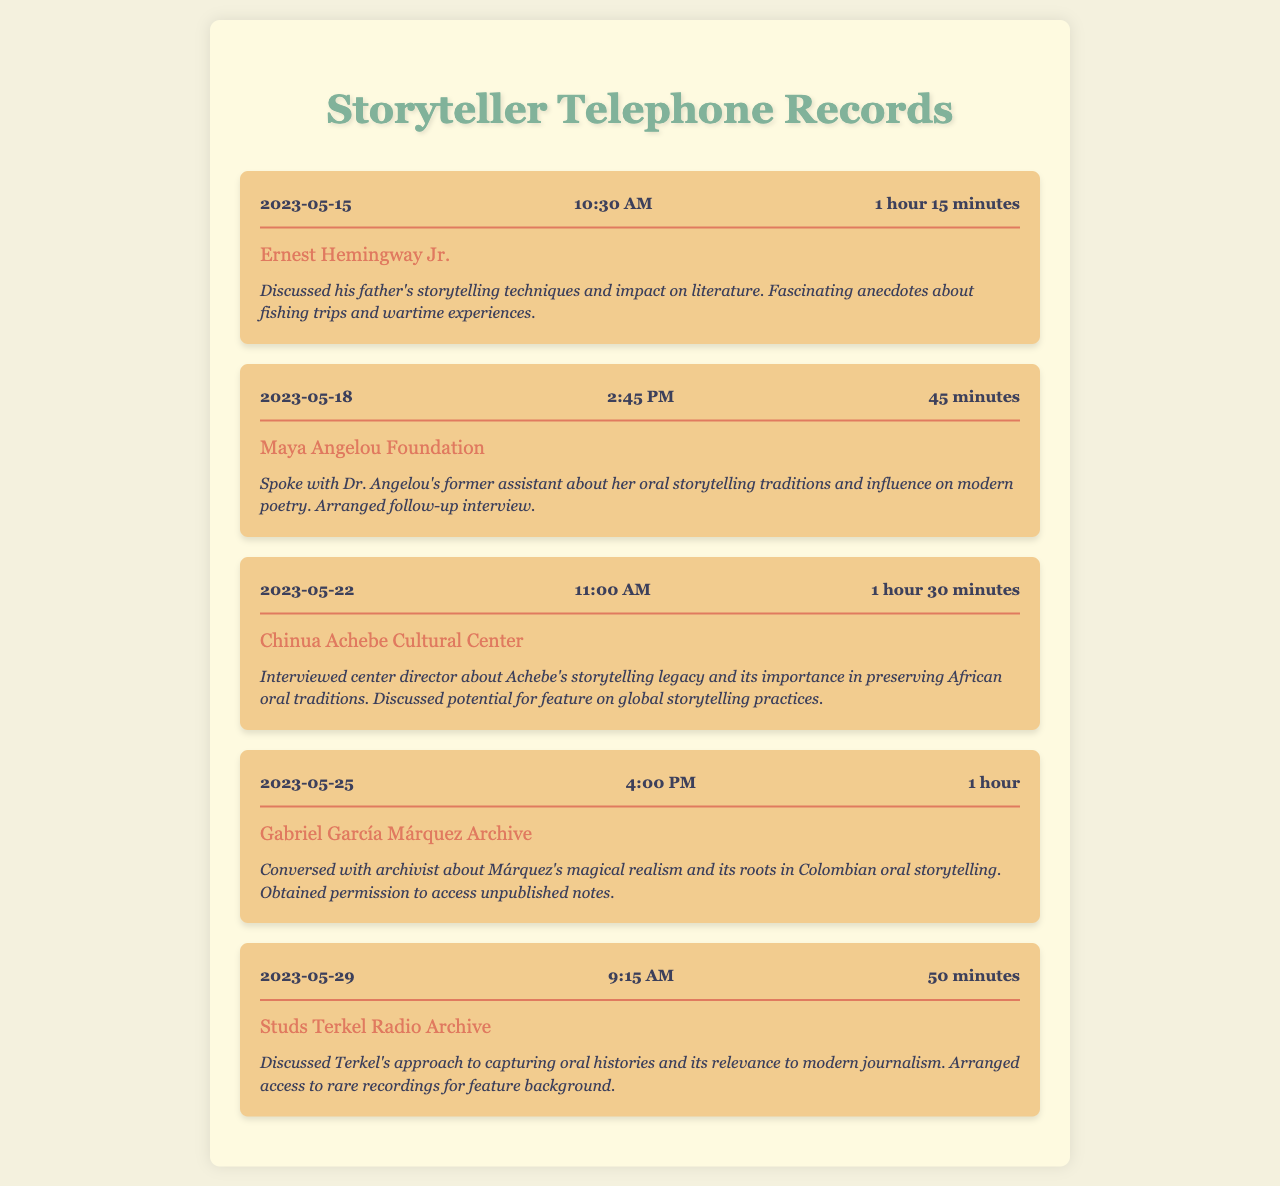What was the date of the first call? The document lists the call records in chronological order, with the first call being on May 15, 2023.
Answer: 2023-05-15 How long was the call with the Maya Angelou Foundation? The call duration for the Maya Angelou Foundation on May 18, 2023, is listed as 45 minutes.
Answer: 45 minutes Who did the journalist speak with on May 22, 2023? The call entry for May 22, 2023, indicates that the journalist spoke with the director of the Chinua Achebe Cultural Center.
Answer: center director What subject was discussed during the call on May 25, 2023? The notes for the call with the Gabriel García Márquez Archive mention discussing Márquez’s magical realism and its roots in Colombian oral storytelling.
Answer: magical realism What was obtained from the Gabriel García Márquez Archive? The notes mention that permission was obtained to access unpublished notes from the archive.
Answer: permission to access unpublished notes How many minutes was the call on May 29, 2023? The document states that the call duration on May 29, 2023, was 50 minutes.
Answer: 50 minutes Which organization's assistant was interviewed about Dr. Angelou's storytelling traditions? The call on May 18, 2023, corresponds to a conversation with Dr. Angelou's former assistant at the Maya Angelou Foundation.
Answer: Maya Angelou Foundation What was discussed in relation to Terkel during the May 29, 2023 call? The call notes indicate that Terkel's approach to capturing oral histories and its relevance to modern journalism were discussed.
Answer: capturing oral histories How many total calls are recorded in the document? By counting the individual call records displayed, there are five calls documented.
Answer: five 